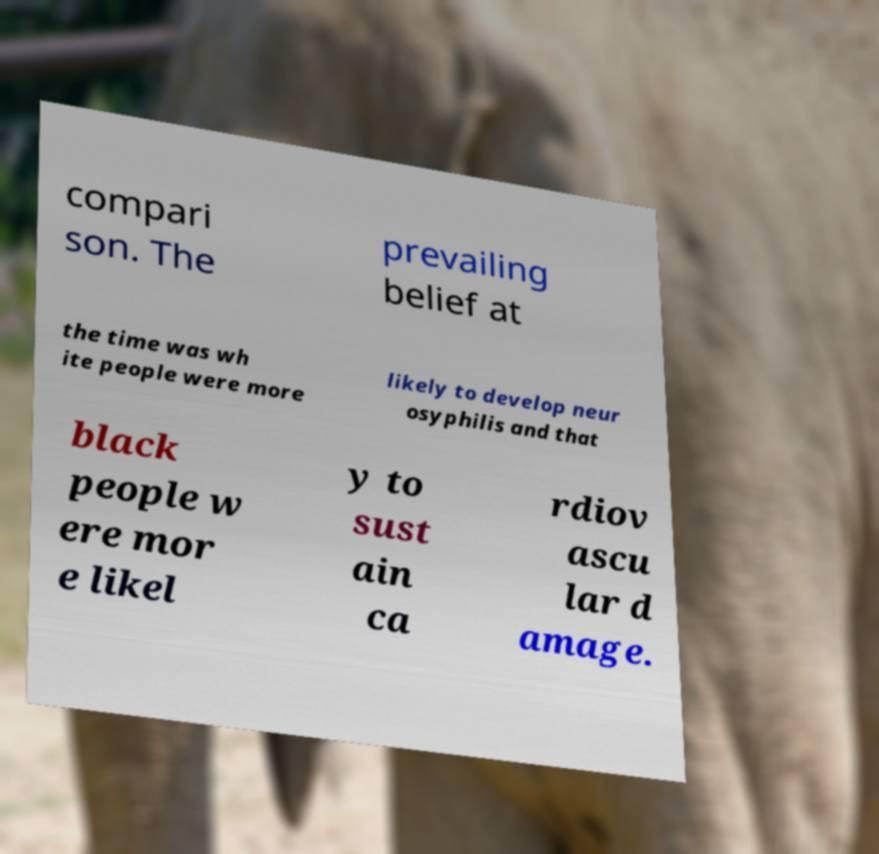I need the written content from this picture converted into text. Can you do that? compari son. The prevailing belief at the time was wh ite people were more likely to develop neur osyphilis and that black people w ere mor e likel y to sust ain ca rdiov ascu lar d amage. 